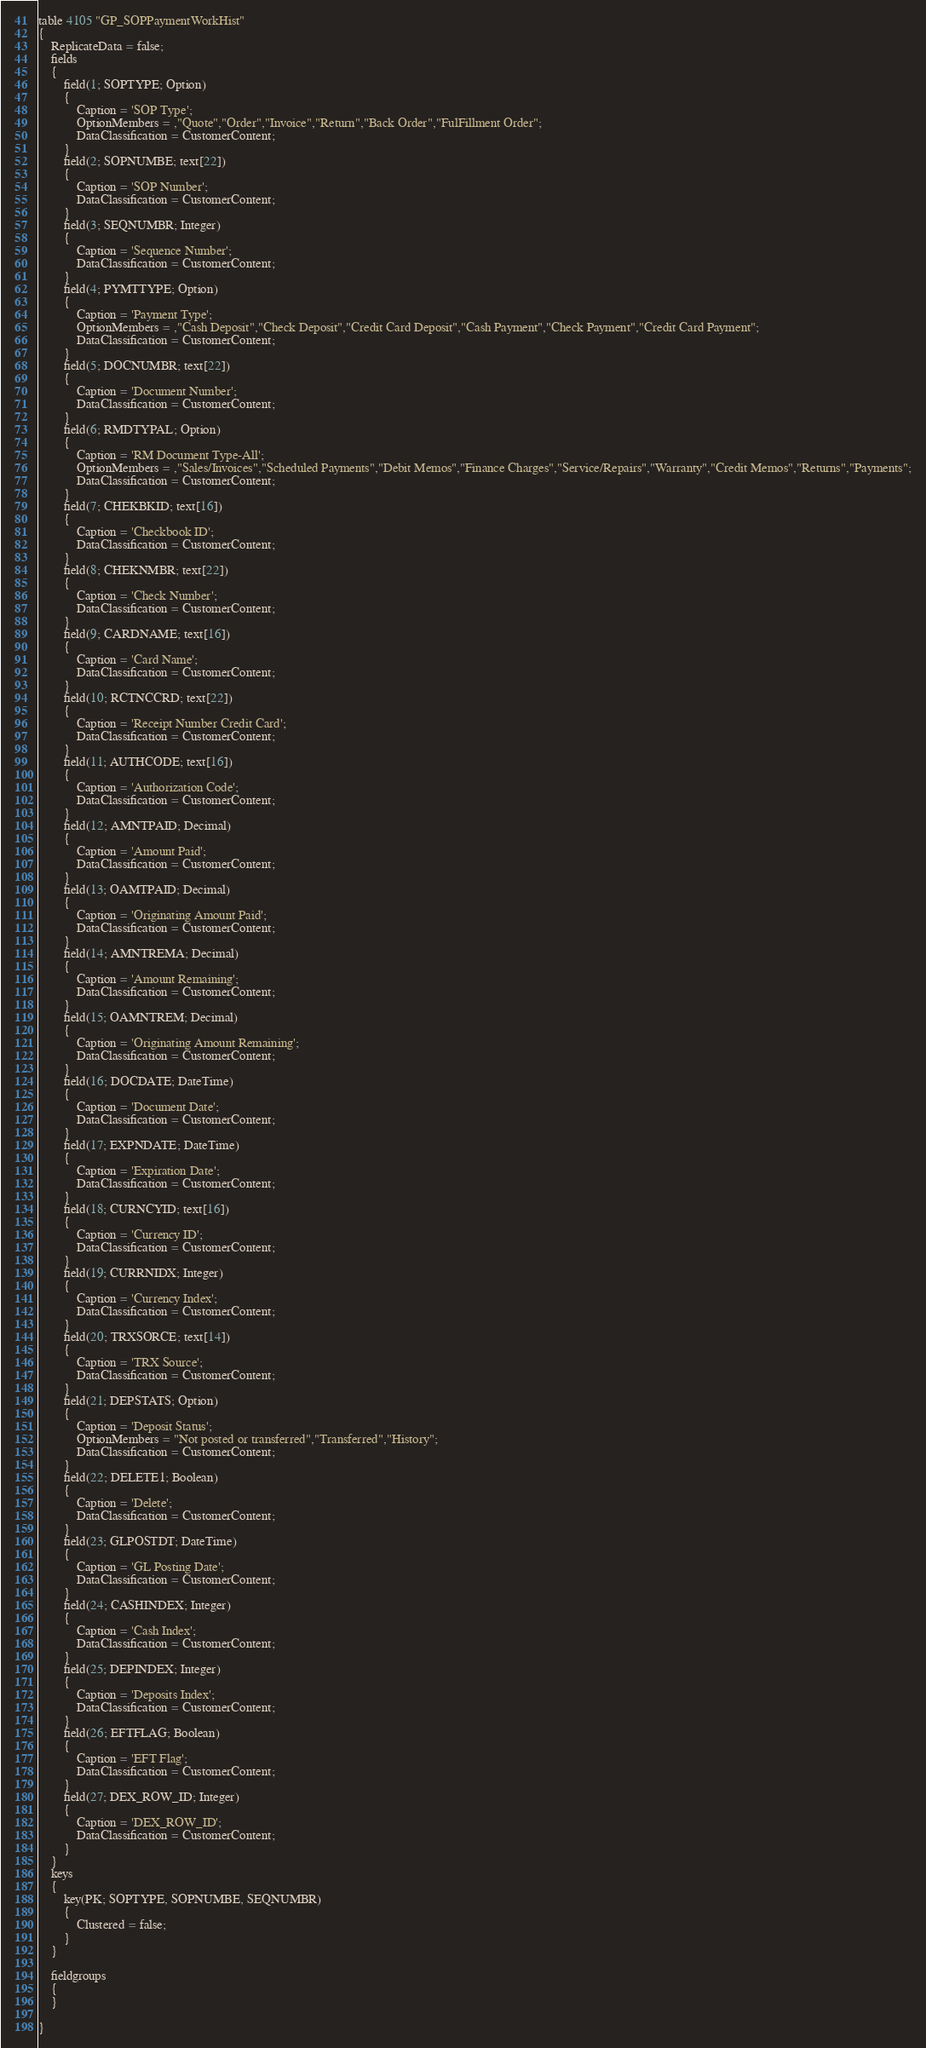Convert code to text. <code><loc_0><loc_0><loc_500><loc_500><_Perl_>table 4105 "GP_SOPPaymentWorkHist"
{
    ReplicateData = false;
    fields
    {
        field(1; SOPTYPE; Option)
        {
            Caption = 'SOP Type';
            OptionMembers = ,"Quote","Order","Invoice","Return","Back Order","FulFillment Order";
            DataClassification = CustomerContent;
        }
        field(2; SOPNUMBE; text[22])
        {
            Caption = 'SOP Number';
            DataClassification = CustomerContent;
        }
        field(3; SEQNUMBR; Integer)
        {
            Caption = 'Sequence Number';
            DataClassification = CustomerContent;
        }
        field(4; PYMTTYPE; Option)
        {
            Caption = 'Payment Type';
            OptionMembers = ,"Cash Deposit","Check Deposit","Credit Card Deposit","Cash Payment","Check Payment","Credit Card Payment";
            DataClassification = CustomerContent;
        }
        field(5; DOCNUMBR; text[22])
        {
            Caption = 'Document Number';
            DataClassification = CustomerContent;
        }
        field(6; RMDTYPAL; Option)
        {
            Caption = 'RM Document Type-All';
            OptionMembers = ,"Sales/Invoices","Scheduled Payments","Debit Memos","Finance Charges","Service/Repairs","Warranty","Credit Memos","Returns","Payments";
            DataClassification = CustomerContent;
        }
        field(7; CHEKBKID; text[16])
        {
            Caption = 'Checkbook ID';
            DataClassification = CustomerContent;
        }
        field(8; CHEKNMBR; text[22])
        {
            Caption = 'Check Number';
            DataClassification = CustomerContent;
        }
        field(9; CARDNAME; text[16])
        {
            Caption = 'Card Name';
            DataClassification = CustomerContent;
        }
        field(10; RCTNCCRD; text[22])
        {
            Caption = 'Receipt Number Credit Card';
            DataClassification = CustomerContent;
        }
        field(11; AUTHCODE; text[16])
        {
            Caption = 'Authorization Code';
            DataClassification = CustomerContent;
        }
        field(12; AMNTPAID; Decimal)
        {
            Caption = 'Amount Paid';
            DataClassification = CustomerContent;
        }
        field(13; OAMTPAID; Decimal)
        {
            Caption = 'Originating Amount Paid';
            DataClassification = CustomerContent;
        }
        field(14; AMNTREMA; Decimal)
        {
            Caption = 'Amount Remaining';
            DataClassification = CustomerContent;
        }
        field(15; OAMNTREM; Decimal)
        {
            Caption = 'Originating Amount Remaining';
            DataClassification = CustomerContent;
        }
        field(16; DOCDATE; DateTime)
        {
            Caption = 'Document Date';
            DataClassification = CustomerContent;
        }
        field(17; EXPNDATE; DateTime)
        {
            Caption = 'Expiration Date';
            DataClassification = CustomerContent;
        }
        field(18; CURNCYID; text[16])
        {
            Caption = 'Currency ID';
            DataClassification = CustomerContent;
        }
        field(19; CURRNIDX; Integer)
        {
            Caption = 'Currency Index';
            DataClassification = CustomerContent;
        }
        field(20; TRXSORCE; text[14])
        {
            Caption = 'TRX Source';
            DataClassification = CustomerContent;
        }
        field(21; DEPSTATS; Option)
        {
            Caption = 'Deposit Status';
            OptionMembers = "Not posted or transferred","Transferred","History";
            DataClassification = CustomerContent;
        }
        field(22; DELETE1; Boolean)
        {
            Caption = 'Delete';
            DataClassification = CustomerContent;
        }
        field(23; GLPOSTDT; DateTime)
        {
            Caption = 'GL Posting Date';
            DataClassification = CustomerContent;
        }
        field(24; CASHINDEX; Integer)
        {
            Caption = 'Cash Index';
            DataClassification = CustomerContent;
        }
        field(25; DEPINDEX; Integer)
        {
            Caption = 'Deposits Index';
            DataClassification = CustomerContent;
        }
        field(26; EFTFLAG; Boolean)
        {
            Caption = 'EFT Flag';
            DataClassification = CustomerContent;
        }
        field(27; DEX_ROW_ID; Integer)
        {
            Caption = 'DEX_ROW_ID';
            DataClassification = CustomerContent;
        }
    }
    keys
    {
        key(PK; SOPTYPE, SOPNUMBE, SEQNUMBR)
        {
            Clustered = false;
        }
    }

    fieldgroups
    {
    }

}
</code> 